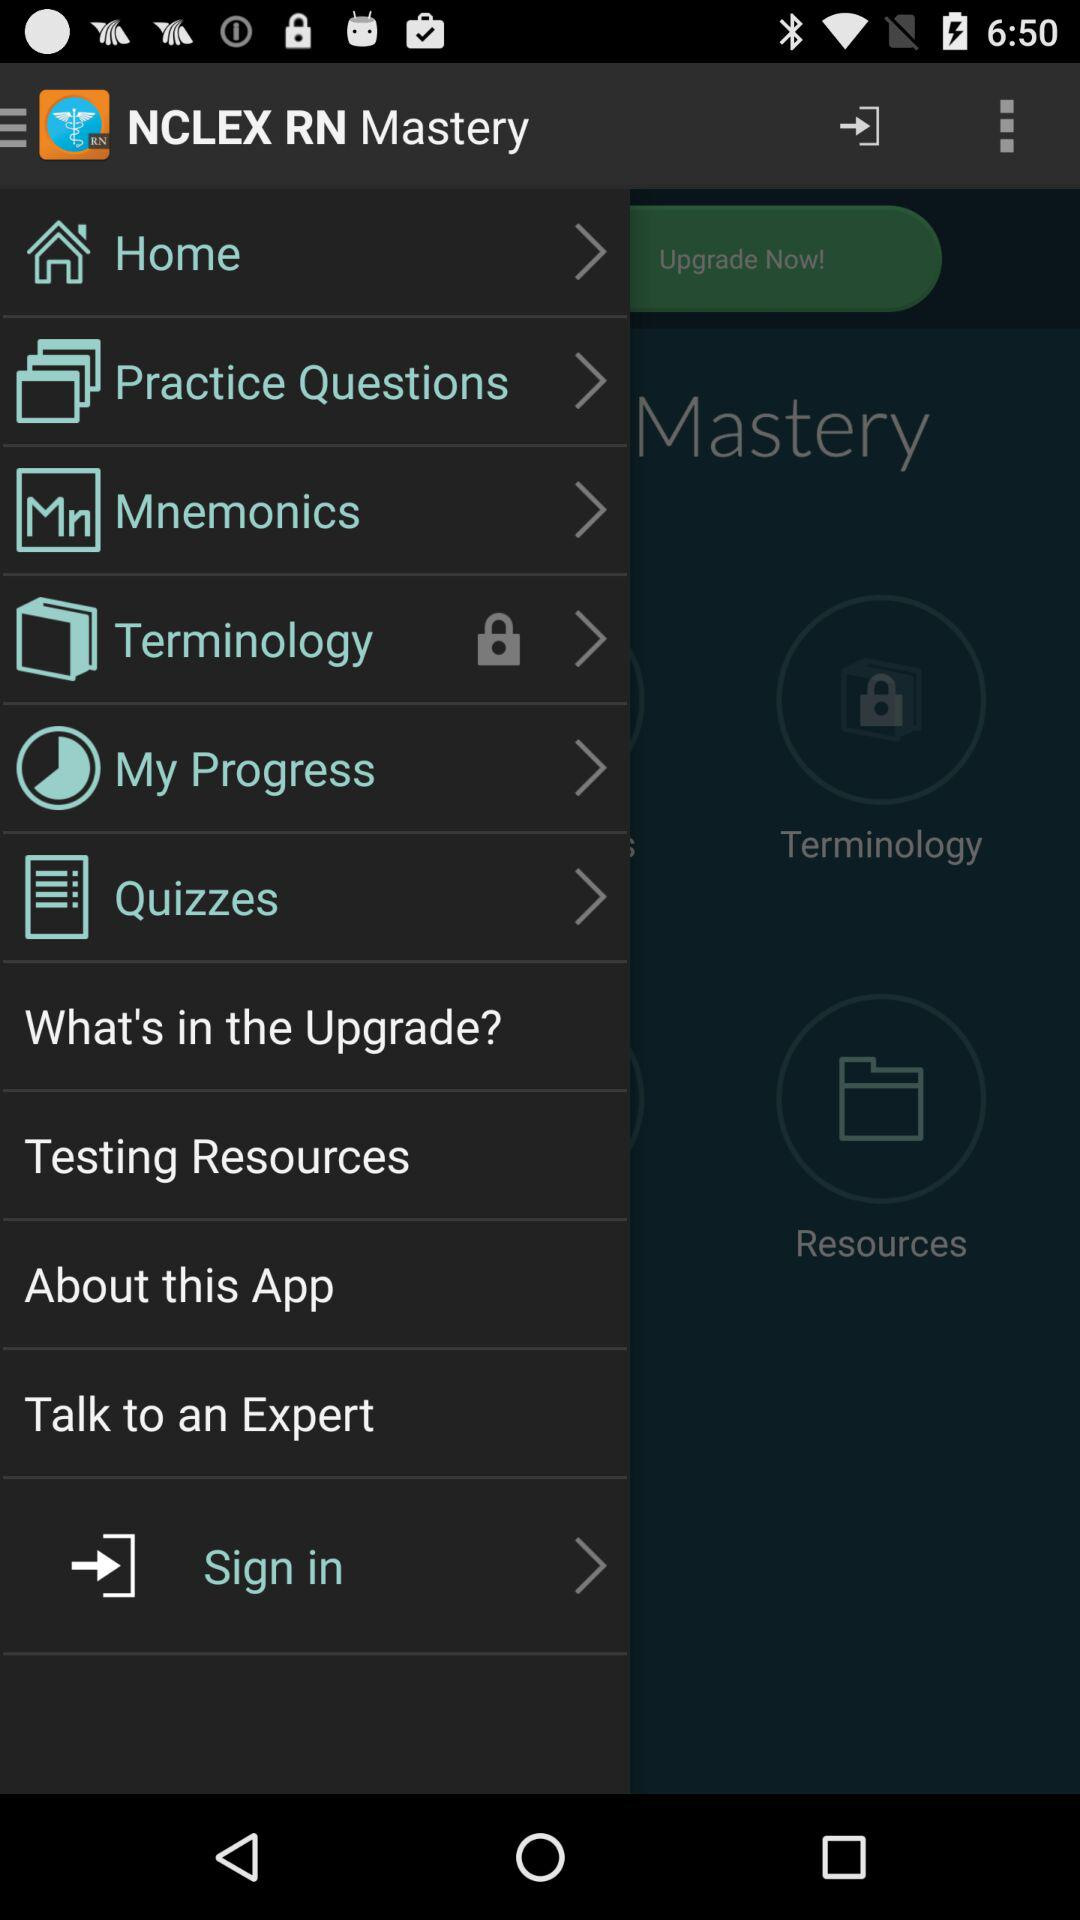How many items are not locked?
Answer the question using a single word or phrase. 5 